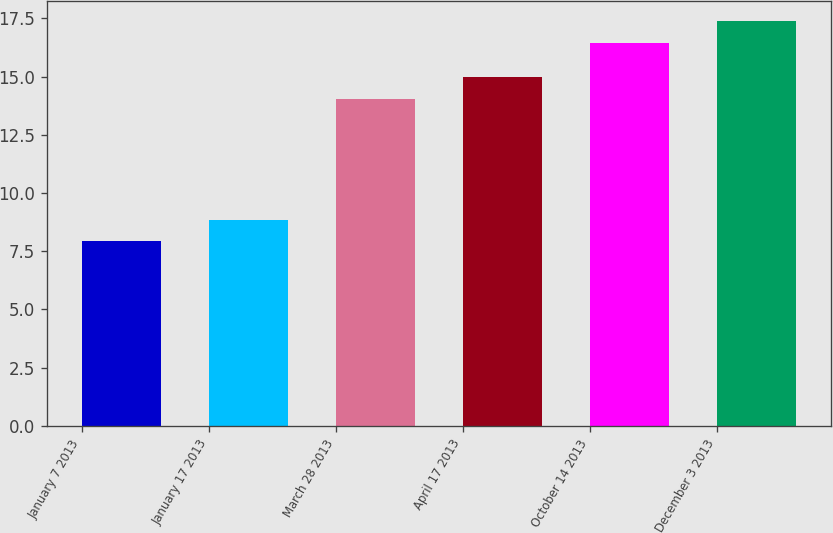Convert chart to OTSL. <chart><loc_0><loc_0><loc_500><loc_500><bar_chart><fcel>January 7 2013<fcel>January 17 2013<fcel>March 28 2013<fcel>April 17 2013<fcel>October 14 2013<fcel>December 3 2013<nl><fcel>7.92<fcel>8.84<fcel>14.04<fcel>14.96<fcel>16.46<fcel>17.38<nl></chart> 